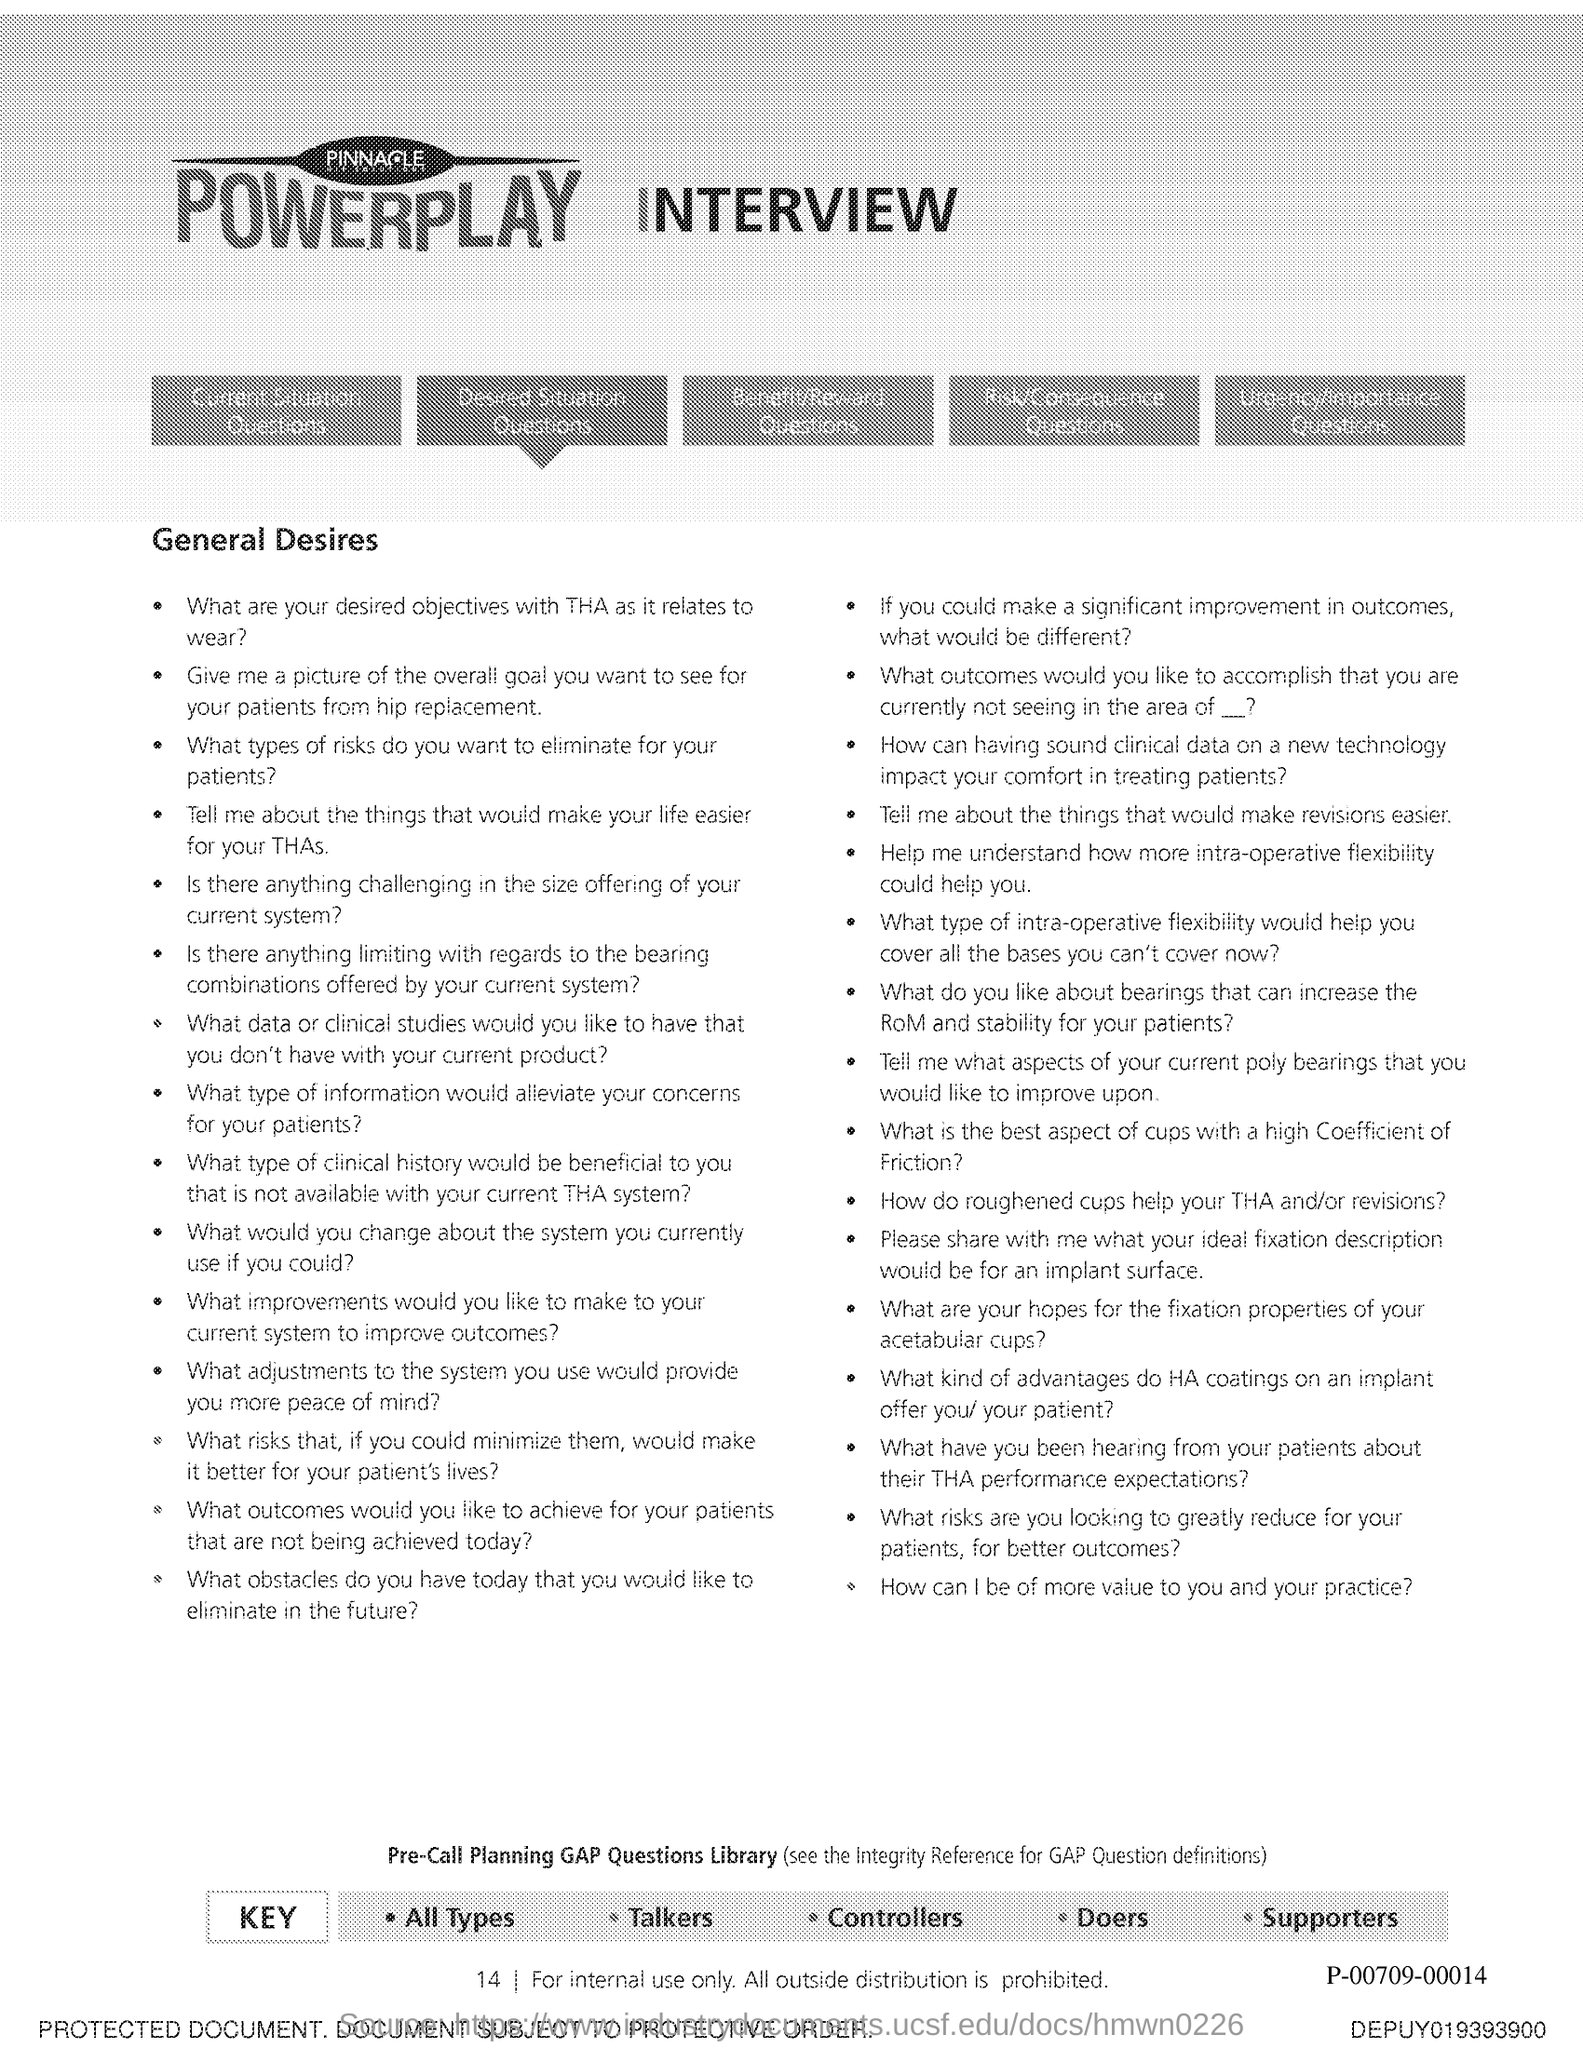Give some essential details in this illustration. The page number is 14. 